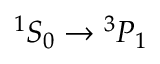<formula> <loc_0><loc_0><loc_500><loc_500>{ } ^ { 1 } S _ { 0 } ^ { 3 } P _ { 1 }</formula> 